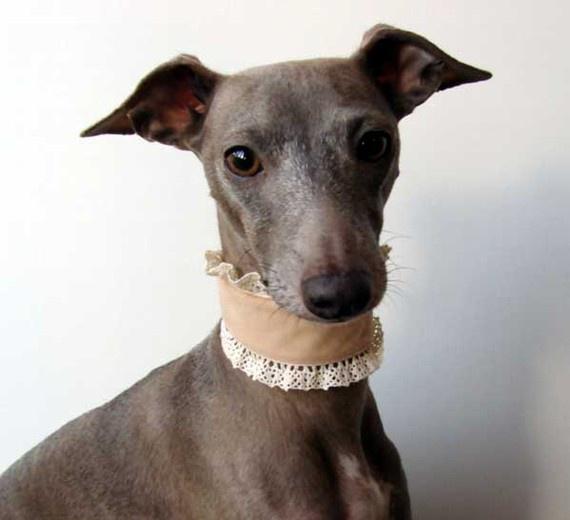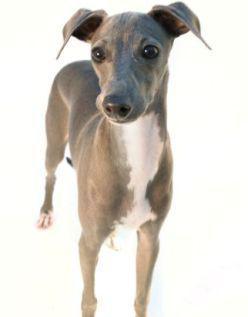The first image is the image on the left, the second image is the image on the right. Considering the images on both sides, is "One of the dogs has a collar." valid? Answer yes or no. Yes. 